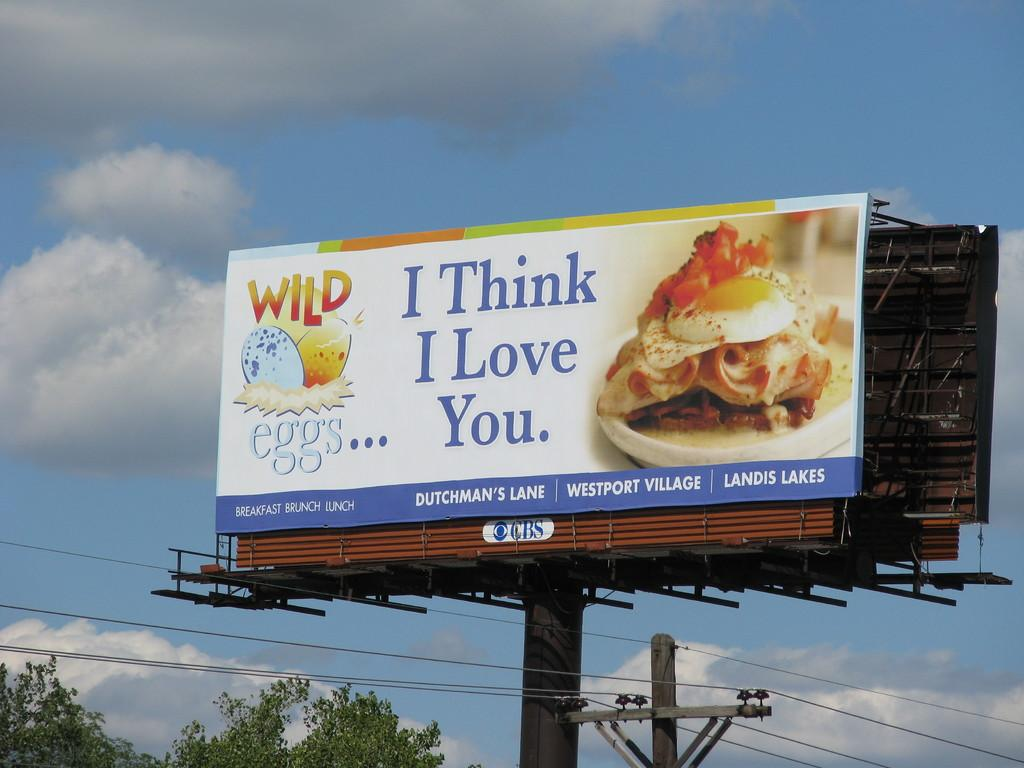<image>
Create a compact narrative representing the image presented. A large billboard says I Think I Love You. 